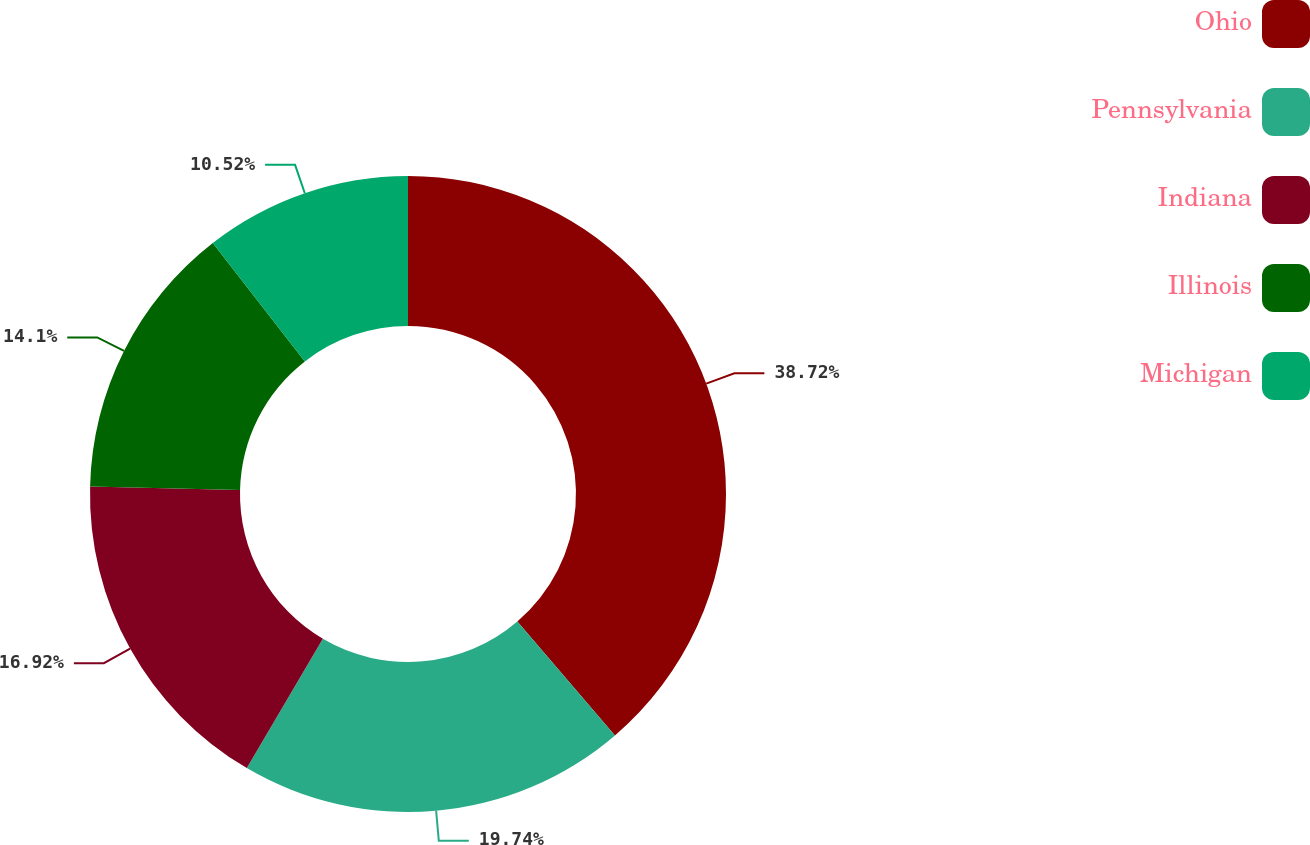<chart> <loc_0><loc_0><loc_500><loc_500><pie_chart><fcel>Ohio<fcel>Pennsylvania<fcel>Indiana<fcel>Illinois<fcel>Michigan<nl><fcel>38.72%<fcel>19.74%<fcel>16.92%<fcel>14.1%<fcel>10.52%<nl></chart> 